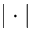<formula> <loc_0><loc_0><loc_500><loc_500>| \cdot |</formula> 